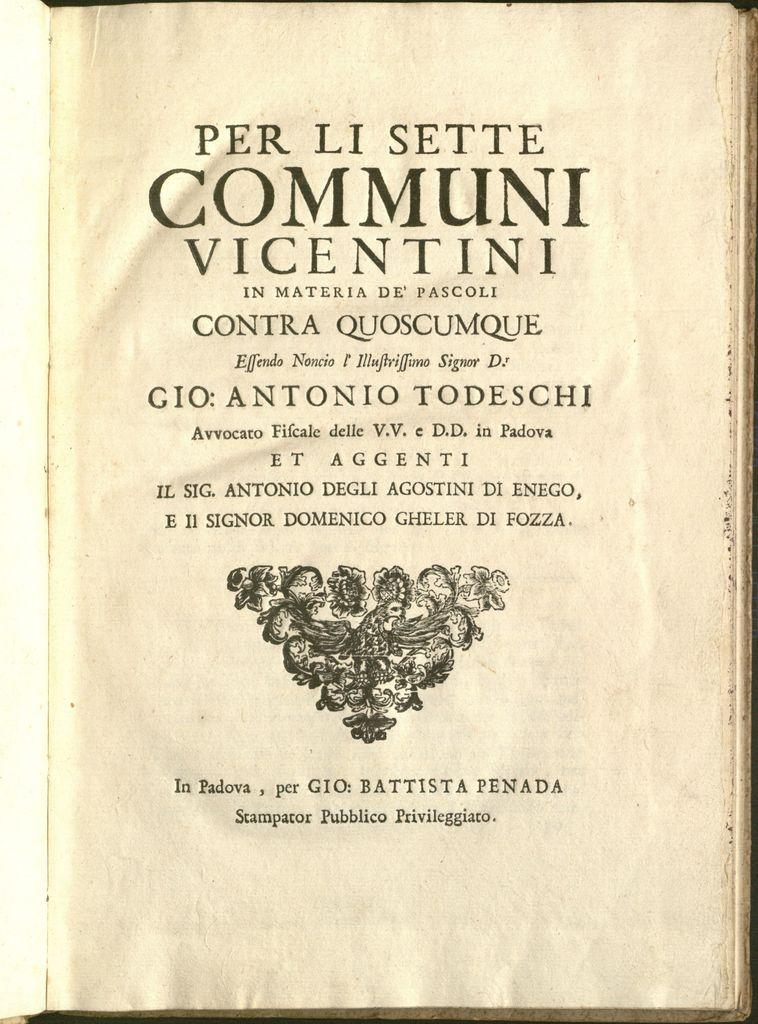<image>
Summarize the visual content of the image. A book is open to the title page which reads Per Li Sette Communi Vicentini. 